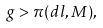<formula> <loc_0><loc_0><loc_500><loc_500>g > \pi ( d l , M ) ,</formula> 